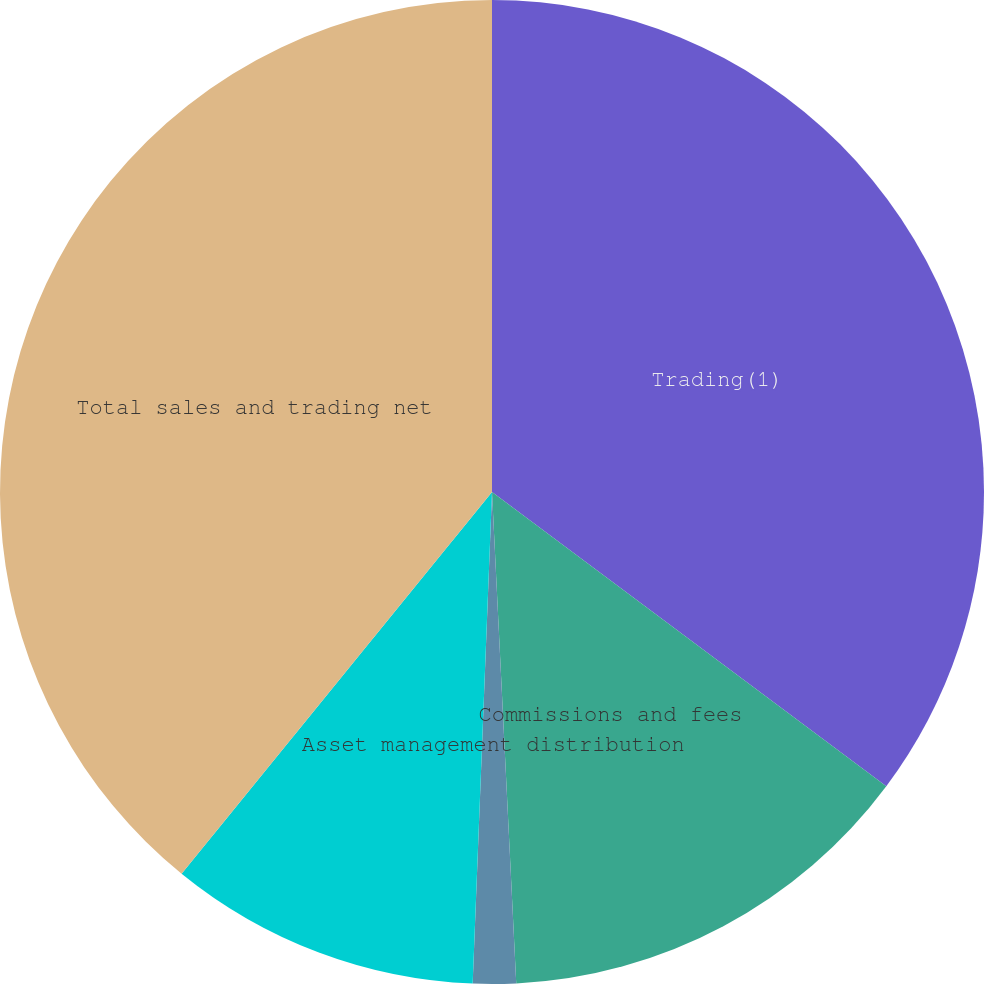Convert chart. <chart><loc_0><loc_0><loc_500><loc_500><pie_chart><fcel>Trading(1)<fcel>Commissions and fees<fcel>Asset management distribution<fcel>Net interest<fcel>Total sales and trading net<nl><fcel>35.2%<fcel>14.01%<fcel>1.41%<fcel>10.24%<fcel>39.13%<nl></chart> 